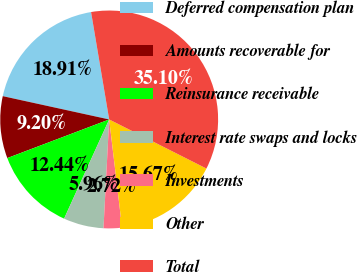<chart> <loc_0><loc_0><loc_500><loc_500><pie_chart><fcel>Deferred compensation plan<fcel>Amounts recoverable for<fcel>Reinsurance receivable<fcel>Interest rate swaps and locks<fcel>Investments<fcel>Other<fcel>Total<nl><fcel>18.91%<fcel>9.2%<fcel>12.44%<fcel>5.96%<fcel>2.72%<fcel>15.67%<fcel>35.1%<nl></chart> 